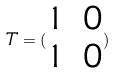<formula> <loc_0><loc_0><loc_500><loc_500>T = ( \begin{matrix} 1 & 0 \\ 1 & 0 \end{matrix} )</formula> 